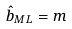<formula> <loc_0><loc_0><loc_500><loc_500>\hat { b } _ { M L } = m</formula> 